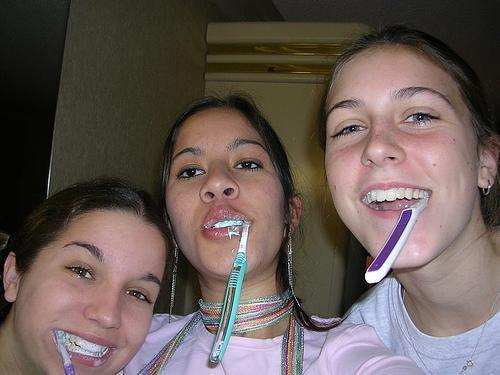How many girls?
Give a very brief answer. 3. How many people can you see?
Give a very brief answer. 3. 